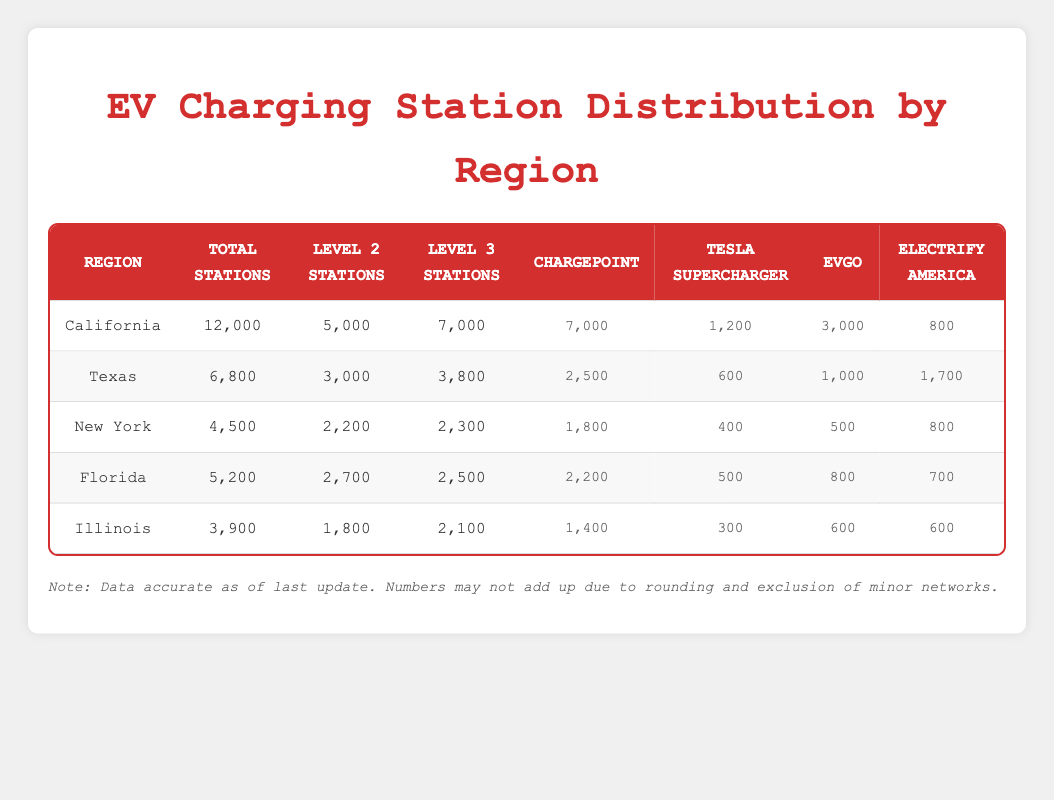What is the total number of charging stations in California? The table shows that California has a total of 12,000 charging stations listed directly under the "Total Stations" column.
Answer: 12,000 Which region has the highest number of Level 3 stations? California has 7,000 Level 3 stations, which is higher than Texas (3,800), New York (2,300), Florida (2,500), and Illinois (2,100). Thus, it has the highest number.
Answer: California How many more ChargePoint stations are there in Florida than in Illinois? Florida has 2,200 ChargePoint stations, while Illinois has 1,400. The difference is calculated as 2,200 - 1,400 = 800.
Answer: 800 Is the number of Tesla Supercharger stations in New York greater than in Florida? New York has 400 Tesla Supercharger stations, and Florida has 500. Since 400 is less than 500, the statement is false.
Answer: No What is the total number of Level 2 stations across all listed regions? To find the total, sum the Level 2 stations: 5,000 (California) + 3,000 (Texas) + 2,200 (New York) + 2,700 (Florida) + 1,800 (Illinois) = 14,700.
Answer: 14,700 Which charging network has the most stations in Texas? The table indicates that ChargePoint has the most stations in Texas with 2,500, compared to Tesla Supercharger (600), EVgo (1,000), and Electrify America (1,700).
Answer: ChargePoint If we look at the total number of charging stations, which state comes third? The total number of charging stations for each state is: California (12,000), Texas (6,800), New York (4,500), Florida (5,200), and Illinois (3,900). When ordered from highest to lowest, New York ranks third.
Answer: New York How many stations does Electify America have in California? Electify America has 800 stations, as specified directly in the table under the California row.
Answer: 800 What is the average number of Level 3 stations per region? The total number of Level 3 stations is 7,000 (California) + 3,800 (Texas) + 2,300 (New York) + 2,500 (Florida) + 2,100 (Illinois) = 17,700. To find the average, divide by 5 regions: 17,700 / 5 = 3,540.
Answer: 3,540 